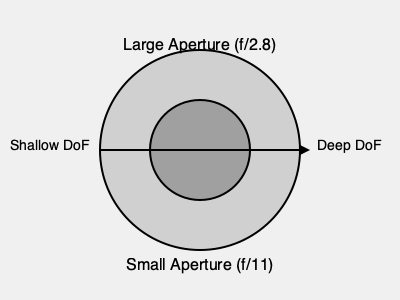You're preparing to capture a family portrait of a father with his triplets in soft, late afternoon sunlight. The father will be positioned slightly in front of the children. Given that you want to ensure all family members are in focus while still maintaining some background blur, what would be the most appropriate aperture setting to use?

A) f/2.8
B) f/5.6
C) f/11
D) f/16 To determine the best aperture setting for this scenario, we need to consider several factors:

1. Depth of Field (DoF): We want all family members in focus, which requires a moderately deep DoF.

2. Subject Positioning: The father is slightly in front of the children, so we need enough DoF to cover this distance.

3. Background Blur: We want some background blur for aesthetic purposes.

4. Lighting Conditions: Soft, late afternoon light typically provides good illumination without harsh shadows.

Let's analyze each option:

A) f/2.8: This is a very wide aperture that creates a shallow DoF. It would likely only keep one person in focus, which is not suitable for this group portrait.

B) f/5.6: This aperture provides a moderate DoF, which could work well for keeping all subjects in focus while still maintaining some background blur.

C) f/11: This smaller aperture creates a deeper DoF, which would ensure all subjects are in focus but might reduce the background blur too much.

D) f/16: This very small aperture creates an even deeper DoF, which is unnecessary for this scenario and may result in a loss of sharpness due to diffraction.

Considering these factors, option B (f/5.6) provides the best balance. It offers enough DoF to keep all family members in focus, even with the slight distance between the father and triplets, while still maintaining some pleasing background blur.

The soft, late afternoon light allows for a moderate aperture without requiring extremely slow shutter speeds or high ISO settings, which could negatively impact image quality.
Answer: f/5.6 